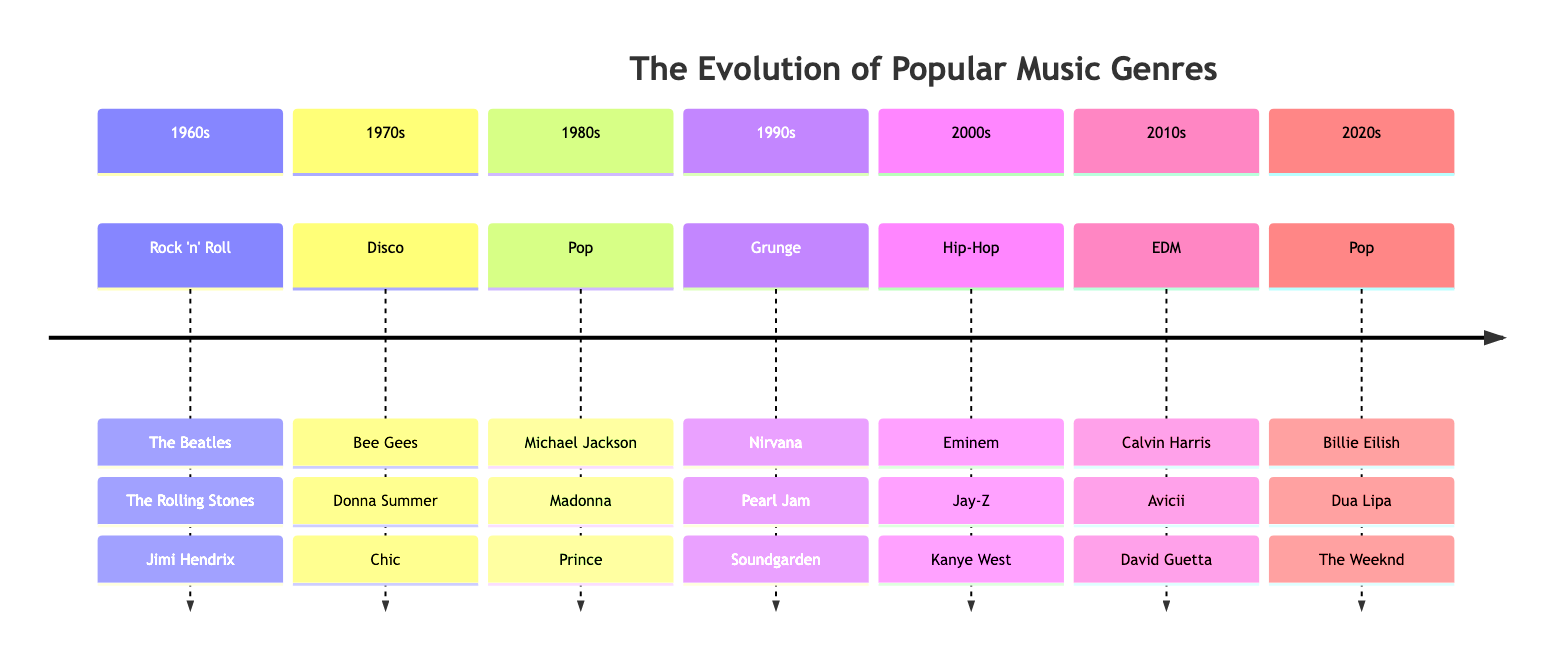What's the dominant genre of the 1960s? The diagram clearly states that the genre for the 1960s is Rock 'n' Roll, as indicated under that decade section.
Answer: Rock 'n' Roll How many key artists are listed for the 1970s? In the 1970s section of the diagram, there are three key artists: Bee Gees, Donna Summer, and Chic. Counting them gives us three.
Answer: 3 Which artist is associated with the key album "Thriller"? Within the 1980s section, Michael Jackson is listed as a key artist, and "Thriller" is named as a key album for that decade. Therefore, Michael Jackson is the associated artist.
Answer: Michael Jackson What is the main genre of the 2000s? The timeline specifies that the genre for the 2000s is Hip-Hop, made evident in the corresponding section.
Answer: Hip-Hop Which decade features the artist Nirvana? Looking at the diagram, Nirvana is mentioned as a key artist in the 1990s section of the timeline.
Answer: 1990s How many key albums are listed for the electronic dance music genre? The EDM section from the 2010s lists three key albums: "18 Months", "True", and "Nothing but the Beat". This gives a total of three key albums.
Answer: 3 Who are the three key artists in the 2020s? In the 2020s section, the key artists mentioned are Billie Eilish, Dua Lipa, and The Weeknd. These three names represent the artists for this decade as per the timeline.
Answer: Billie Eilish, Dua Lipa, The Weeknd Which decades feature Pop as the main genre? Examining the timeline, Pop is listed as the main genre for both the 1980s and the 2020s sections. This gives us two distinct decades featuring Pop.
Answer: 1980s, 2020s Why is Grunge significant in the 1990s? The significance of Grunge in the 1990s can be noted as it encompasses key artists like Nirvana, Pearl Jam, and Soundgarden, along with impactful albums, indicating its popularity and influence in that decade.
Answer: Key genre and influence in the 1990s 